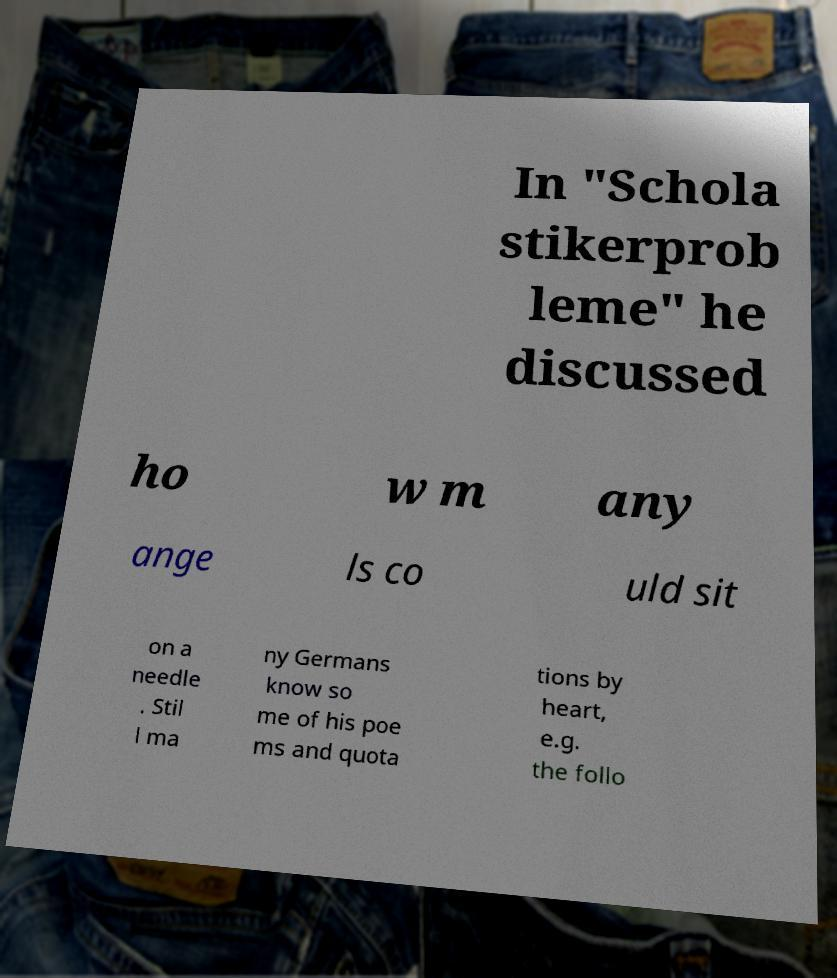Could you extract and type out the text from this image? In "Schola stikerprob leme" he discussed ho w m any ange ls co uld sit on a needle . Stil l ma ny Germans know so me of his poe ms and quota tions by heart, e.g. the follo 